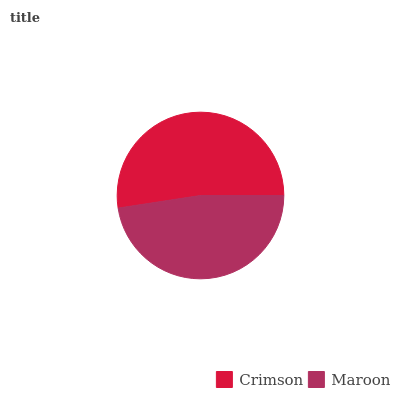Is Maroon the minimum?
Answer yes or no. Yes. Is Crimson the maximum?
Answer yes or no. Yes. Is Maroon the maximum?
Answer yes or no. No. Is Crimson greater than Maroon?
Answer yes or no. Yes. Is Maroon less than Crimson?
Answer yes or no. Yes. Is Maroon greater than Crimson?
Answer yes or no. No. Is Crimson less than Maroon?
Answer yes or no. No. Is Crimson the high median?
Answer yes or no. Yes. Is Maroon the low median?
Answer yes or no. Yes. Is Maroon the high median?
Answer yes or no. No. Is Crimson the low median?
Answer yes or no. No. 